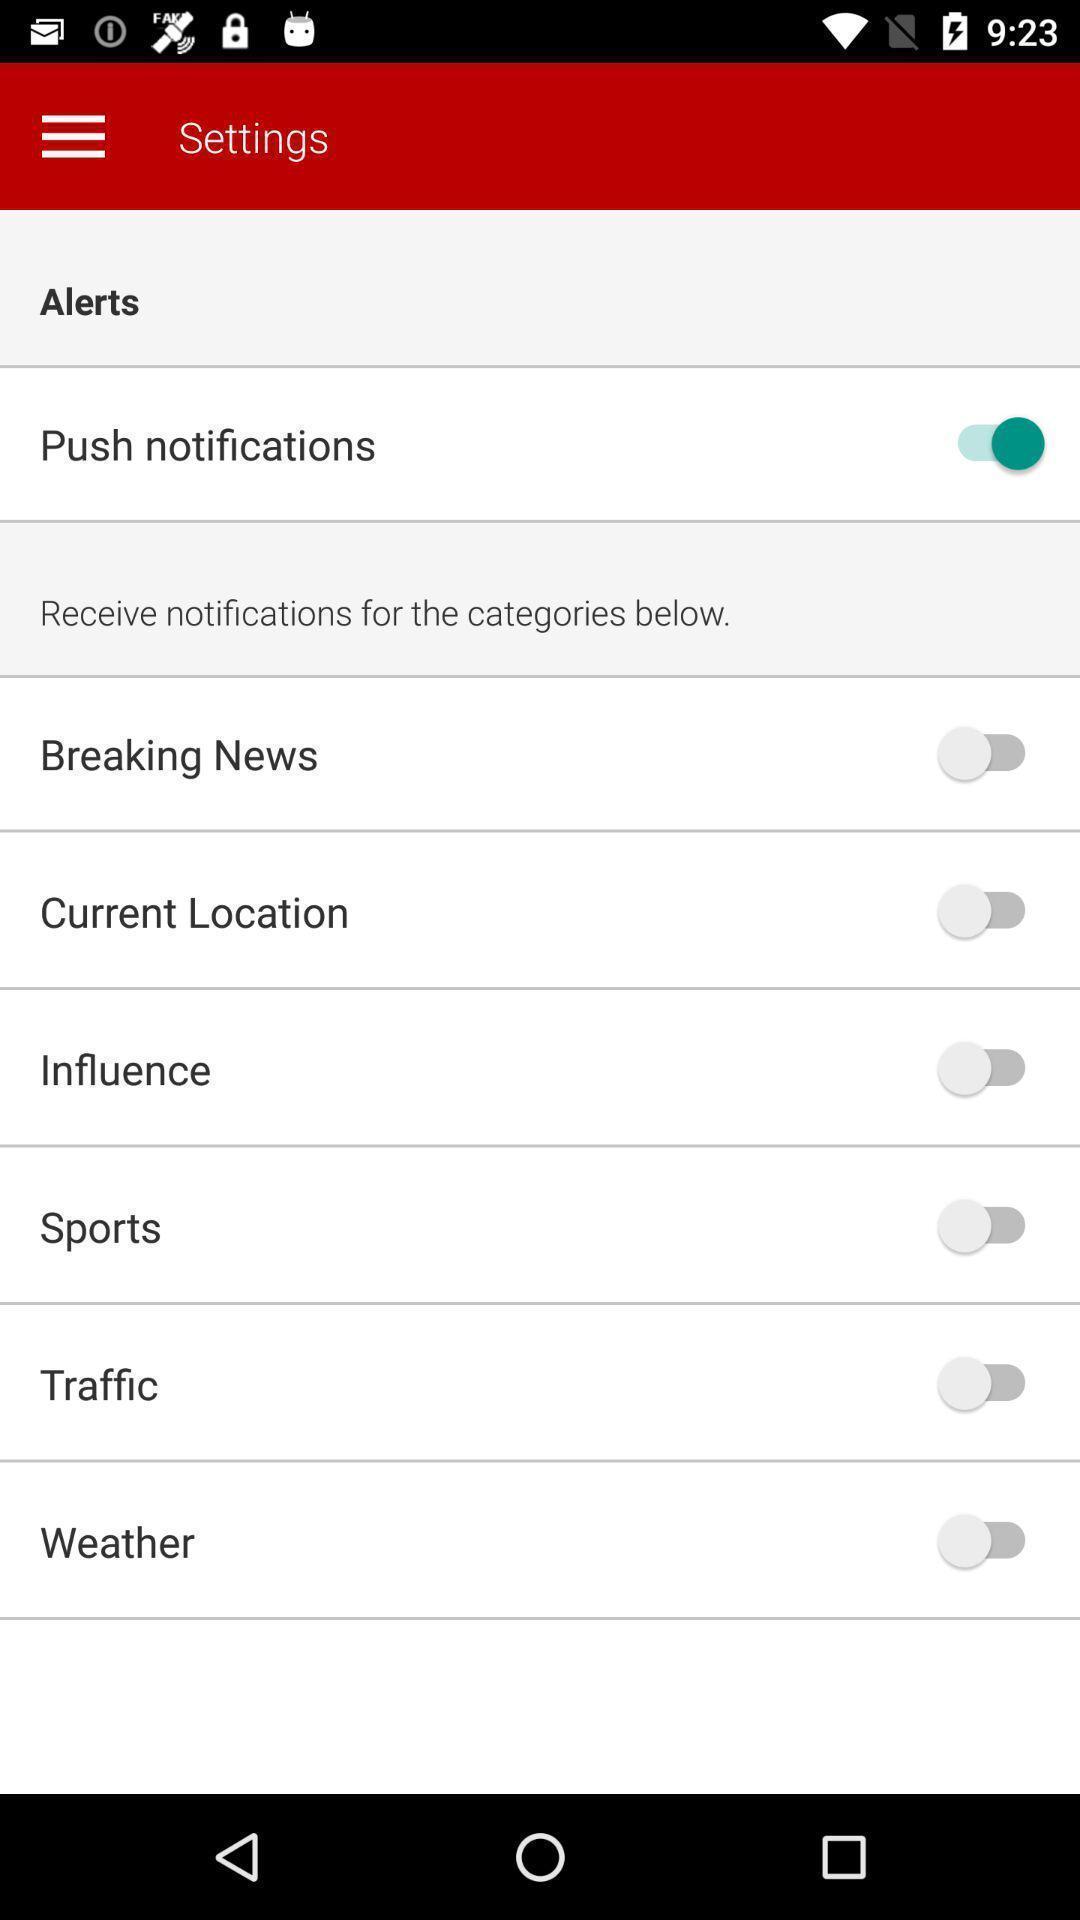Please provide a description for this image. Screen displaying the settings page. 